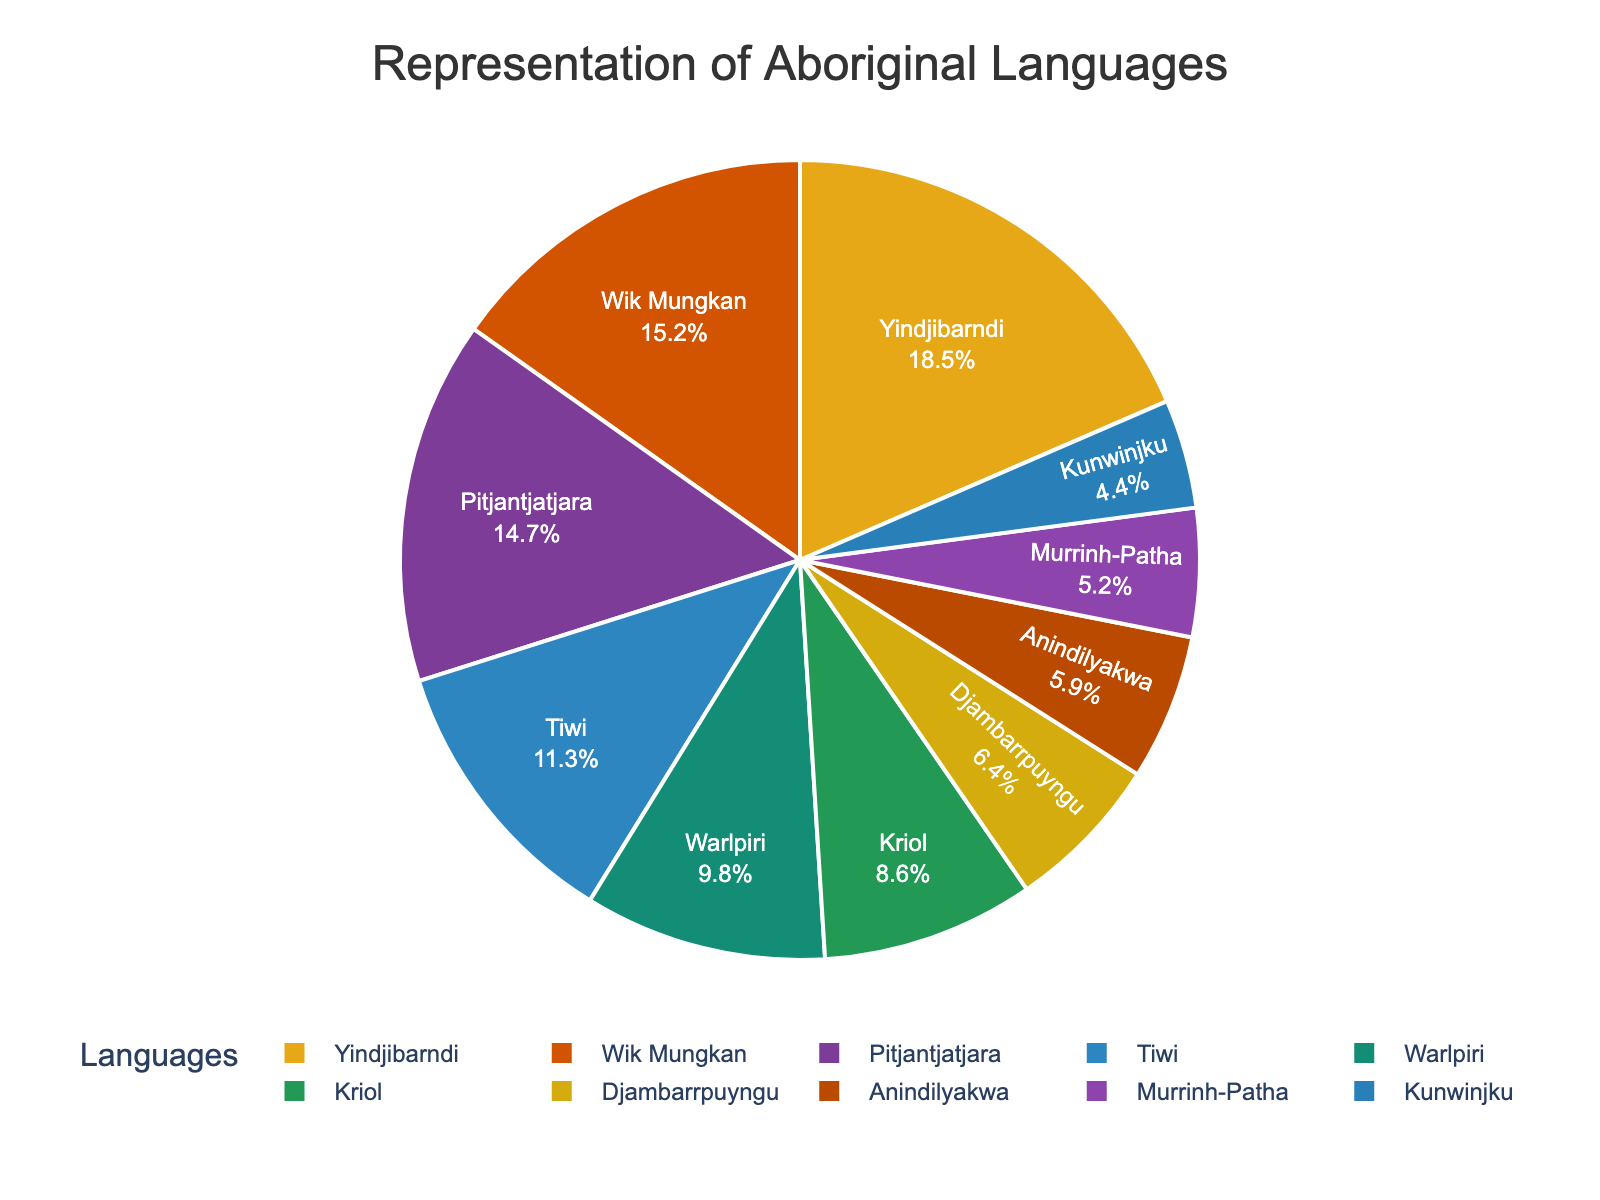What is the most spoken Aboriginal language in the pie chart? Identify the language segment with the largest slice (18.5%) from the pie chart labeled "Yindjibarndi."
Answer: Yindjibarndi Which Aboriginal language has the smallest representation in the pie chart? Identify the language segment with the smallest slice (4.4%) from the pie chart labeled "Kunwinjku."
Answer: Kunwinjku How much greater is the percentage representation of Yindjibarndi compared to Kriol? Find the percentage of Yindjibarndi (18.5%) and Kriol (8.6%), then subtract the smaller from the larger value: 18.5 - 8.6 = 9.9%
Answer: 9.9% What is the combined percentage of the two least represented Aboriginal languages? Find the percentages of "Murrinh-Patha" (5.2%) and "Kunwinjku" (4.4%), then add them together: 5.2 + 4.4 = 9.6%
Answer: 9.6% Which languages have a representation greater than 10%? Identify the segments that represent more than 10%: "Yindjibarndi" (18.5%), "Wik Mungkan" (15.2%), "Pitjantjatjara" (14.7%), and "Tiwi" (11.3%)
Answer: Yindjibarndi, Wik Mungkan, Pitjantjatjara, Tiwi If the percentages of Warlpiri and Djambarrpuyngu were combined, would it surpass the percentage of Yindjibarndi? Add the percentages of Warlpiri (9.8%) and Djambarrpuyngu (6.4%): 9.8 + 6.4 = 16.2%. Compare this to Yindjibarndi's 18.5%. 16.2 < 18.5, so it does not surpass.
Answer: No What color represents the language Wik Mungkan? Refer to the color coding in the pie chart: Wik Mungkan is represented by the color orange (#D35400).
Answer: Orange Which languages together occupy about 30% of the total representation? Sum percentages until reaching around 30%. Wik Mungkan (15.2%) + Pitjantjatjara (14.7%) = 29.9%, which is close to 30%.
Answer: Wik Mungkan and Pitjantjatjara How much more represented is Tiwi compared to Murrinh-Patha? Subtract the percentage of Murrinh-Patha (5.2%) from the percentage of Tiwi (11.3%): 11.3 - 5.2 = 6.1%
Answer: 6.1% What is the total percentage of the languages represented by green and purple shades? According to the custom color palette, find the percentages for these colors. Green: Tiwi (11.3%), Warlpiri (9.8%), Djambarrpuyngu (6.4%). Purple: Pitjantjatjara (14.7%), Anindilyakwa (5.9%). Sum these: 11.3 + 9.8 + 6.4 + 14.7 + 5.9 = 48.1%
Answer: 48.1% 